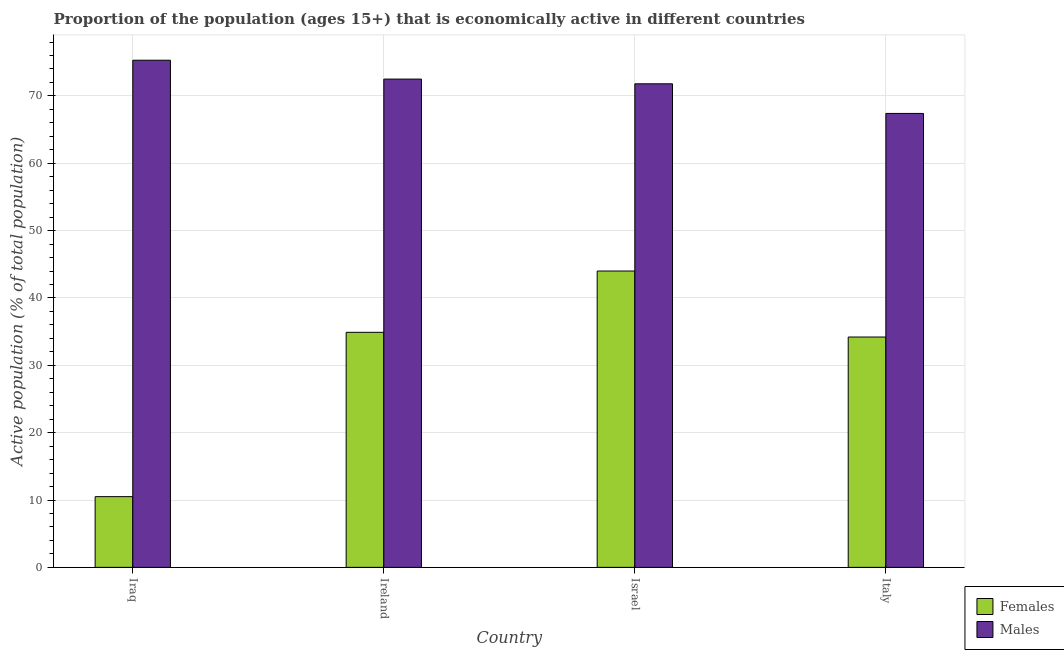How many groups of bars are there?
Your answer should be compact. 4. Are the number of bars per tick equal to the number of legend labels?
Offer a very short reply. Yes. Are the number of bars on each tick of the X-axis equal?
Provide a succinct answer. Yes. What is the label of the 1st group of bars from the left?
Make the answer very short. Iraq. In how many cases, is the number of bars for a given country not equal to the number of legend labels?
Ensure brevity in your answer.  0. What is the percentage of economically active male population in Israel?
Provide a short and direct response. 71.8. Across all countries, what is the minimum percentage of economically active male population?
Provide a short and direct response. 67.4. In which country was the percentage of economically active female population minimum?
Offer a terse response. Iraq. What is the total percentage of economically active male population in the graph?
Give a very brief answer. 287. What is the difference between the percentage of economically active female population in Iraq and that in Israel?
Provide a succinct answer. -33.5. What is the difference between the percentage of economically active male population in Italy and the percentage of economically active female population in Ireland?
Offer a terse response. 32.5. What is the average percentage of economically active female population per country?
Your answer should be compact. 30.9. What is the difference between the percentage of economically active female population and percentage of economically active male population in Ireland?
Keep it short and to the point. -37.6. In how many countries, is the percentage of economically active female population greater than 36 %?
Provide a short and direct response. 1. What is the ratio of the percentage of economically active male population in Iraq to that in Italy?
Keep it short and to the point. 1.12. Is the percentage of economically active female population in Ireland less than that in Israel?
Give a very brief answer. Yes. What is the difference between the highest and the second highest percentage of economically active male population?
Your answer should be compact. 2.8. What is the difference between the highest and the lowest percentage of economically active male population?
Your answer should be compact. 7.9. In how many countries, is the percentage of economically active female population greater than the average percentage of economically active female population taken over all countries?
Offer a very short reply. 3. What does the 1st bar from the left in Italy represents?
Your answer should be very brief. Females. What does the 2nd bar from the right in Ireland represents?
Your response must be concise. Females. Are all the bars in the graph horizontal?
Your answer should be very brief. No. What is the difference between two consecutive major ticks on the Y-axis?
Provide a succinct answer. 10. Are the values on the major ticks of Y-axis written in scientific E-notation?
Give a very brief answer. No. Does the graph contain any zero values?
Offer a very short reply. No. Does the graph contain grids?
Offer a terse response. Yes. Where does the legend appear in the graph?
Provide a succinct answer. Bottom right. How many legend labels are there?
Ensure brevity in your answer.  2. How are the legend labels stacked?
Keep it short and to the point. Vertical. What is the title of the graph?
Make the answer very short. Proportion of the population (ages 15+) that is economically active in different countries. What is the label or title of the X-axis?
Provide a short and direct response. Country. What is the label or title of the Y-axis?
Your answer should be very brief. Active population (% of total population). What is the Active population (% of total population) of Males in Iraq?
Keep it short and to the point. 75.3. What is the Active population (% of total population) of Females in Ireland?
Ensure brevity in your answer.  34.9. What is the Active population (% of total population) of Males in Ireland?
Provide a succinct answer. 72.5. What is the Active population (% of total population) in Females in Israel?
Make the answer very short. 44. What is the Active population (% of total population) of Males in Israel?
Your answer should be compact. 71.8. What is the Active population (% of total population) of Females in Italy?
Your response must be concise. 34.2. What is the Active population (% of total population) of Males in Italy?
Keep it short and to the point. 67.4. Across all countries, what is the maximum Active population (% of total population) of Males?
Provide a short and direct response. 75.3. Across all countries, what is the minimum Active population (% of total population) of Females?
Your response must be concise. 10.5. Across all countries, what is the minimum Active population (% of total population) of Males?
Keep it short and to the point. 67.4. What is the total Active population (% of total population) of Females in the graph?
Your answer should be very brief. 123.6. What is the total Active population (% of total population) in Males in the graph?
Offer a very short reply. 287. What is the difference between the Active population (% of total population) of Females in Iraq and that in Ireland?
Your answer should be compact. -24.4. What is the difference between the Active population (% of total population) of Females in Iraq and that in Israel?
Keep it short and to the point. -33.5. What is the difference between the Active population (% of total population) of Females in Iraq and that in Italy?
Make the answer very short. -23.7. What is the difference between the Active population (% of total population) in Males in Iraq and that in Italy?
Keep it short and to the point. 7.9. What is the difference between the Active population (% of total population) in Females in Ireland and that in Israel?
Make the answer very short. -9.1. What is the difference between the Active population (% of total population) of Males in Ireland and that in Israel?
Give a very brief answer. 0.7. What is the difference between the Active population (% of total population) of Females in Ireland and that in Italy?
Your response must be concise. 0.7. What is the difference between the Active population (% of total population) of Females in Israel and that in Italy?
Your answer should be compact. 9.8. What is the difference between the Active population (% of total population) in Males in Israel and that in Italy?
Give a very brief answer. 4.4. What is the difference between the Active population (% of total population) of Females in Iraq and the Active population (% of total population) of Males in Ireland?
Give a very brief answer. -62. What is the difference between the Active population (% of total population) in Females in Iraq and the Active population (% of total population) in Males in Israel?
Your answer should be compact. -61.3. What is the difference between the Active population (% of total population) of Females in Iraq and the Active population (% of total population) of Males in Italy?
Your answer should be compact. -56.9. What is the difference between the Active population (% of total population) of Females in Ireland and the Active population (% of total population) of Males in Israel?
Ensure brevity in your answer.  -36.9. What is the difference between the Active population (% of total population) in Females in Ireland and the Active population (% of total population) in Males in Italy?
Make the answer very short. -32.5. What is the difference between the Active population (% of total population) of Females in Israel and the Active population (% of total population) of Males in Italy?
Offer a very short reply. -23.4. What is the average Active population (% of total population) of Females per country?
Ensure brevity in your answer.  30.9. What is the average Active population (% of total population) in Males per country?
Your response must be concise. 71.75. What is the difference between the Active population (% of total population) in Females and Active population (% of total population) in Males in Iraq?
Give a very brief answer. -64.8. What is the difference between the Active population (% of total population) of Females and Active population (% of total population) of Males in Ireland?
Make the answer very short. -37.6. What is the difference between the Active population (% of total population) of Females and Active population (% of total population) of Males in Israel?
Provide a succinct answer. -27.8. What is the difference between the Active population (% of total population) of Females and Active population (% of total population) of Males in Italy?
Your answer should be very brief. -33.2. What is the ratio of the Active population (% of total population) in Females in Iraq to that in Ireland?
Your response must be concise. 0.3. What is the ratio of the Active population (% of total population) in Males in Iraq to that in Ireland?
Your answer should be compact. 1.04. What is the ratio of the Active population (% of total population) of Females in Iraq to that in Israel?
Provide a succinct answer. 0.24. What is the ratio of the Active population (% of total population) of Males in Iraq to that in Israel?
Your answer should be very brief. 1.05. What is the ratio of the Active population (% of total population) in Females in Iraq to that in Italy?
Ensure brevity in your answer.  0.31. What is the ratio of the Active population (% of total population) in Males in Iraq to that in Italy?
Offer a very short reply. 1.12. What is the ratio of the Active population (% of total population) in Females in Ireland to that in Israel?
Your answer should be very brief. 0.79. What is the ratio of the Active population (% of total population) of Males in Ireland to that in Israel?
Keep it short and to the point. 1.01. What is the ratio of the Active population (% of total population) of Females in Ireland to that in Italy?
Keep it short and to the point. 1.02. What is the ratio of the Active population (% of total population) of Males in Ireland to that in Italy?
Keep it short and to the point. 1.08. What is the ratio of the Active population (% of total population) of Females in Israel to that in Italy?
Give a very brief answer. 1.29. What is the ratio of the Active population (% of total population) of Males in Israel to that in Italy?
Offer a very short reply. 1.07. What is the difference between the highest and the second highest Active population (% of total population) in Males?
Provide a succinct answer. 2.8. What is the difference between the highest and the lowest Active population (% of total population) in Females?
Your answer should be very brief. 33.5. 